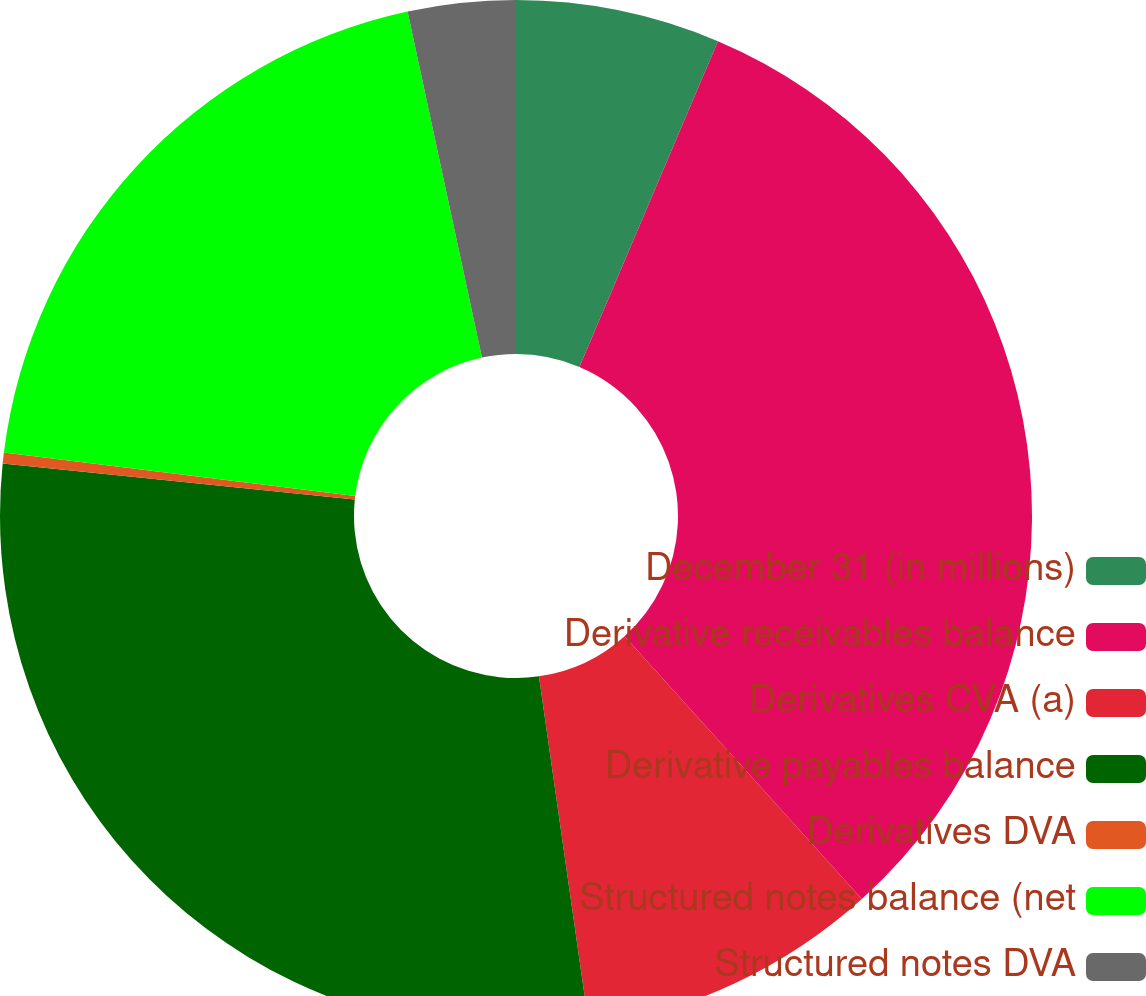Convert chart. <chart><loc_0><loc_0><loc_500><loc_500><pie_chart><fcel>December 31 (in millions)<fcel>Derivative receivables balance<fcel>Derivatives CVA (a)<fcel>Derivative payables balance<fcel>Derivatives DVA<fcel>Structured notes balance (net<fcel>Structured notes DVA<nl><fcel>6.4%<fcel>31.91%<fcel>9.43%<fcel>28.88%<fcel>0.34%<fcel>19.67%<fcel>3.37%<nl></chart> 